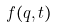<formula> <loc_0><loc_0><loc_500><loc_500>f ( q , t )</formula> 